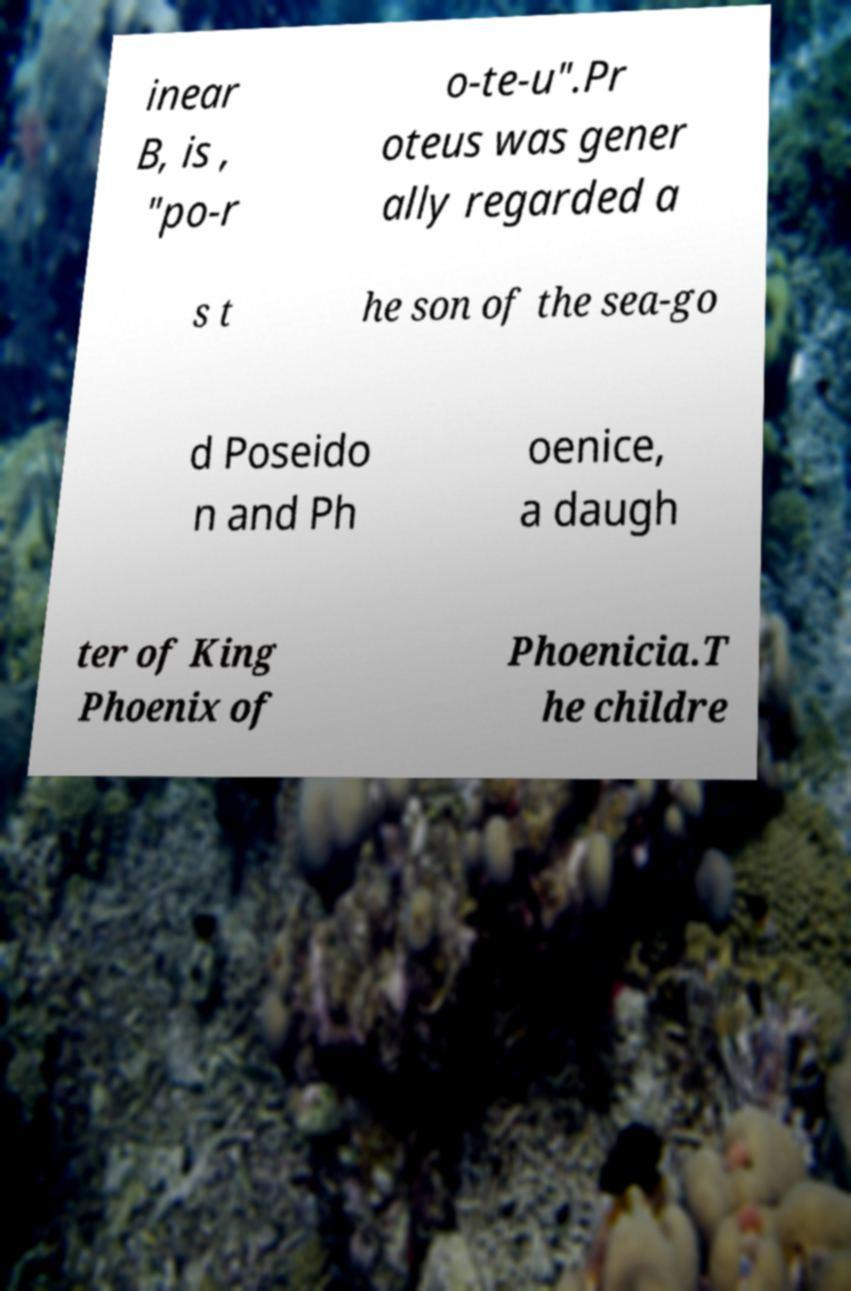What messages or text are displayed in this image? I need them in a readable, typed format. inear B, is , "po-r o-te-u".Pr oteus was gener ally regarded a s t he son of the sea-go d Poseido n and Ph oenice, a daugh ter of King Phoenix of Phoenicia.T he childre 